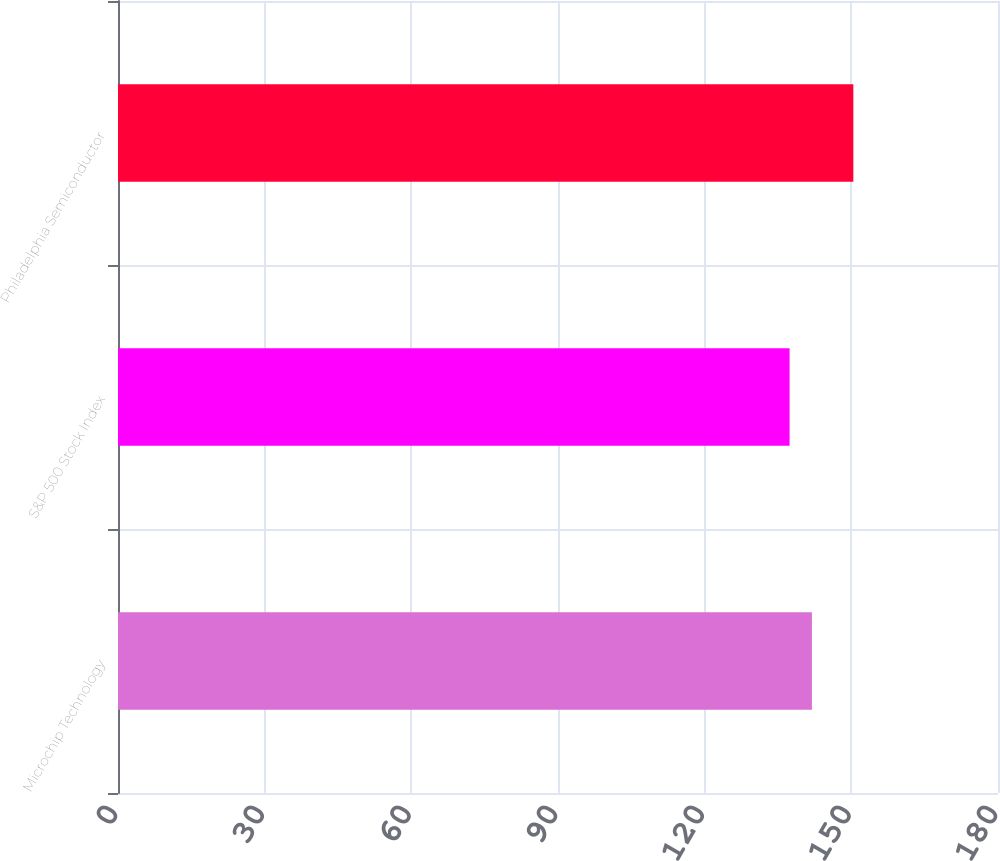Convert chart. <chart><loc_0><loc_0><loc_500><loc_500><bar_chart><fcel>Microchip Technology<fcel>S&P 500 Stock Index<fcel>Philadelphia Semiconductor<nl><fcel>141.94<fcel>137.37<fcel>150.41<nl></chart> 